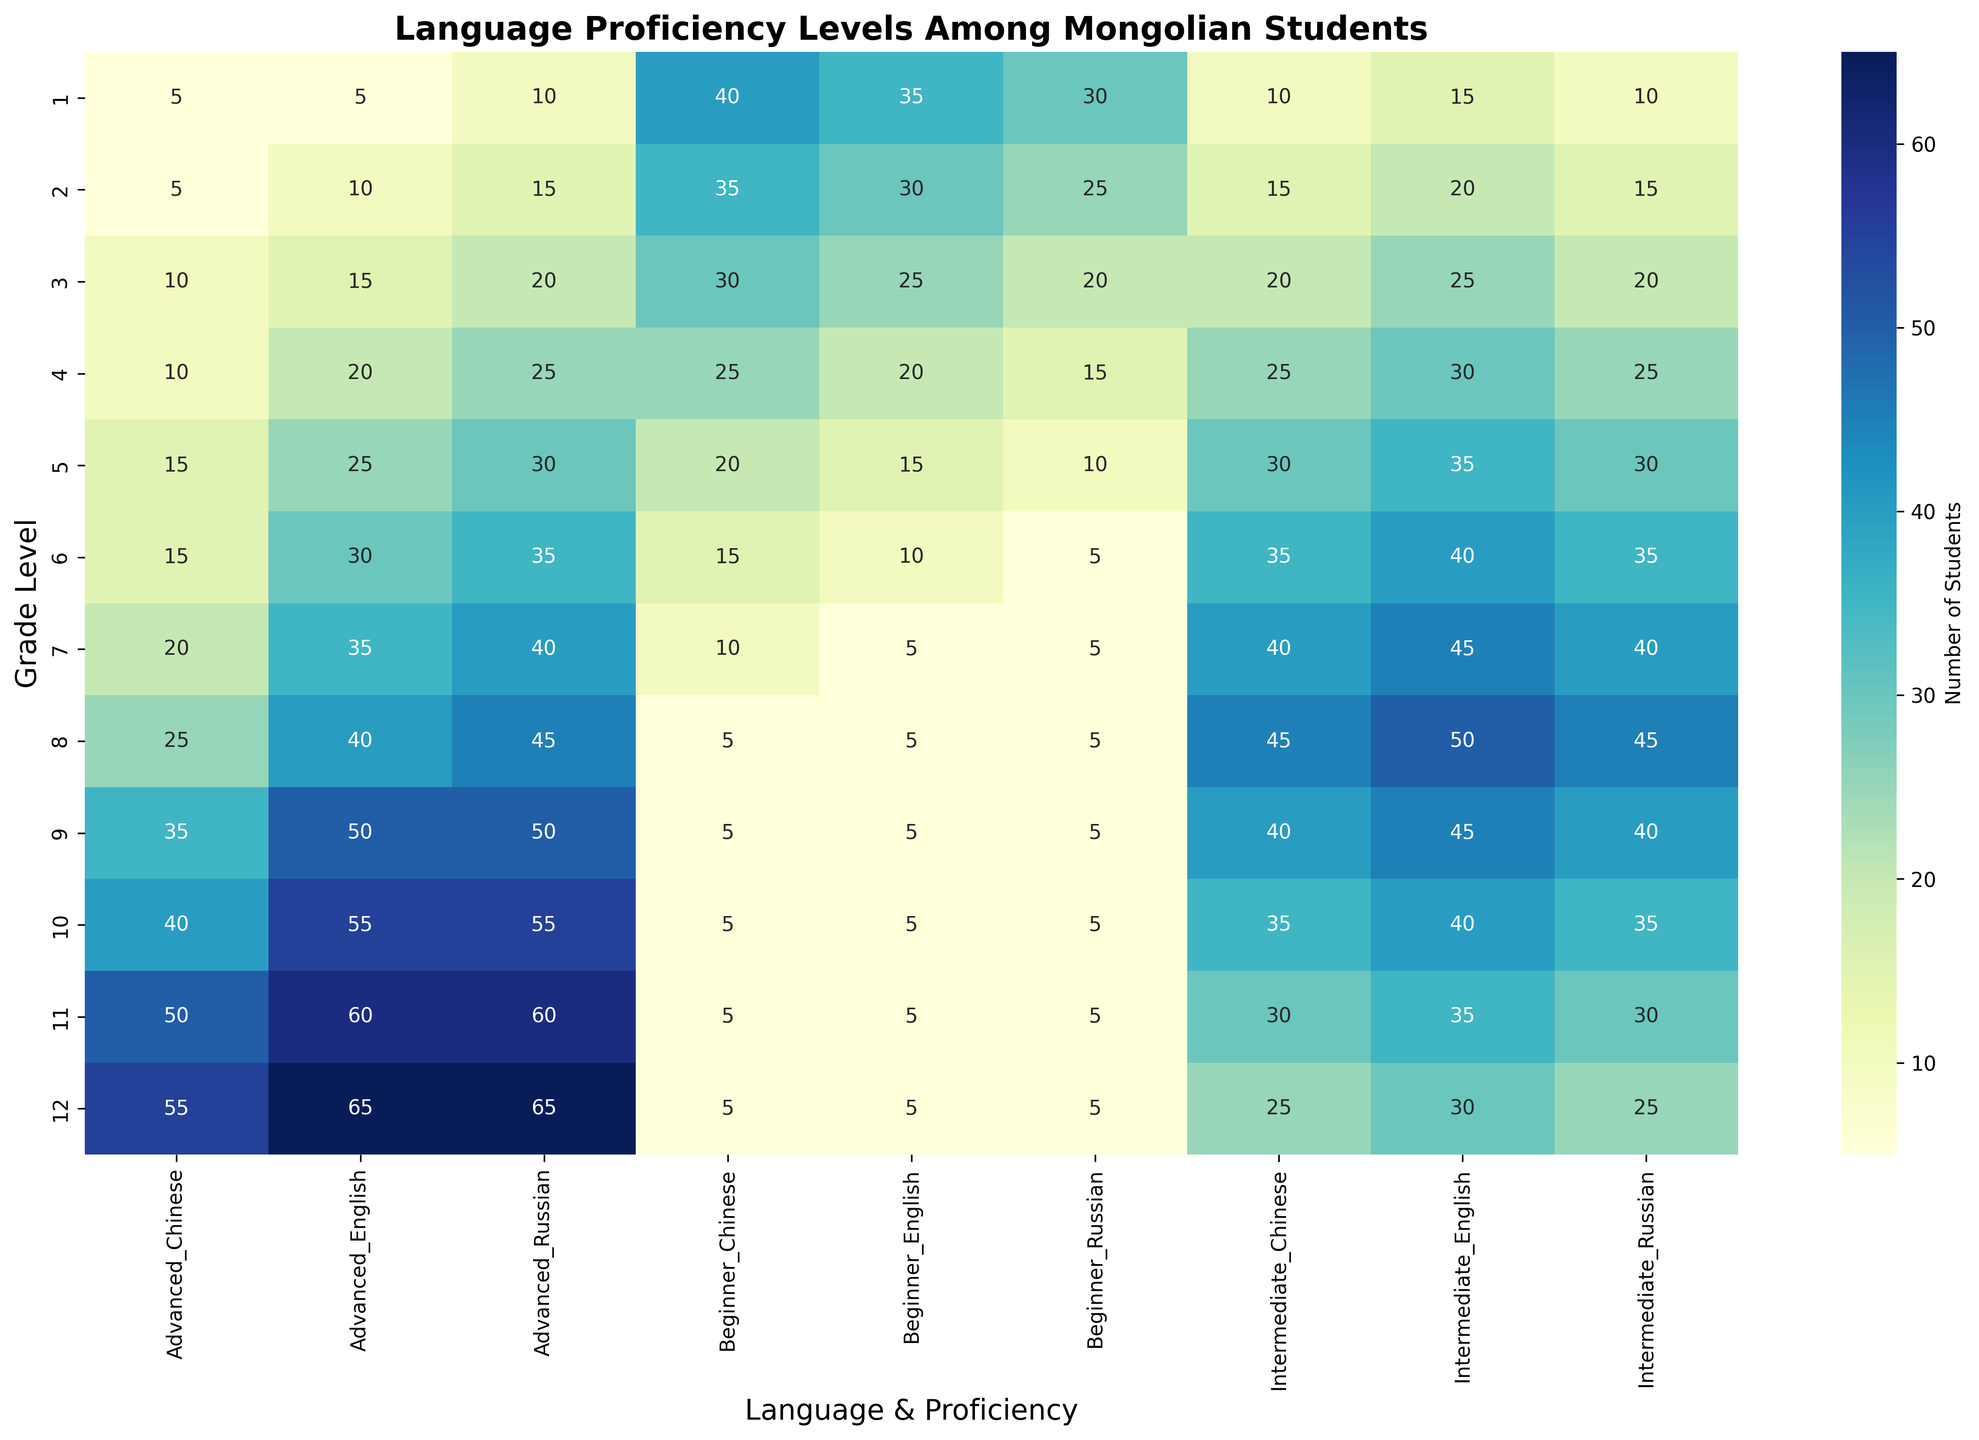What's the highest number of students in the advanced level for any language and grade? We look at the "Advanced" column for each language and find the highest value. Check each language (English, Chinese, Russian) and grade levels (1 to 12). The highest value is 65 for both English in grade 12 and Russian in grade 12.
Answer: 65 Between grades 1 and 5, which language had the most students at the intermediate level? Sum the intermediate levels for grades 1 to 5 for each language. English: 15+20+25+30+35 = 125, Chinese: 10+15+20+25+30 = 100, Russian: 10+15+20+25+30 = 100. English had the most students.
Answer: English In grade 7, how many students are at the beginner level in total for all languages? Add the beginner levels for English, Chinese, and Russian in grade 7. English: 5, Chinese: 10, Russian: 5. 5+10+5 = 20.
Answer: 20 Which grade had the highest number of advanced-level students for Chinese? Compare the advanced-level students of Chinese across all grades. The highest numbers are 55 in grade 12.
Answer: Grade 12 Are there any grades where the number of intermediate-level students in all languages is equal? Compare the intermediate levels across grades. In no grade are the intermediate levels for all three languages equal.
Answer: No Which language saw the most significant increase in the number of advanced-level students from grade 1 to grade 12? Evaluate the increase in advanced-level students from grade 1 to grade 12 for each language. English: 65-5 = 60, Chinese: 55-5 = 50, Russian: 65-10 = 55. English had the most significant increase.
Answer: English In grade 6, which language had the highest combined number of students across all proficiency levels? Sum the beginner, intermediate, and advanced levels for English, Chinese, and Russian in grade 6. English: 10+40+30=80, Chinese: 15+35+15=65, Russian: 5+35+35=75. English had the highest combined number.
Answer: English For grades 8 to 10, how many total students are at the advanced level for Russian? Sum the advanced levels for grades 8 to 10 for Russian. 45+50+55 = 150.
Answer: 150 What is the trend in the number of beginner students for English from grade 1 to grade 12? Observe the beginner levels for English from grade 1 to grade 12: 35, 30, 25, 20, 15, 10, 5, 5, 5, 5, 5, 5. The number decreases initially and then remains constant from grade 7 to 12.
Answer: Decreasing then constant Which proficiency level saw the smallest change in the number of students for Chinese from grade 1 to grade 12? Compare the differences in the number of beginner, intermediate, and advanced students for Chinese from grade 1 to 12. Beginner: 5-40 = -35, Intermediate: 25-10 = 15, Advanced: 55-5 = 50. The intermediate level saw the smallest change (+15).
Answer: Intermediate 